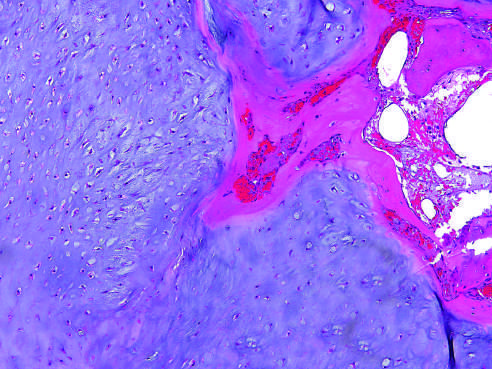s enchondroma composed of a nodule of hyaline cartilage encased by a thin layer of reactive bone?
Answer the question using a single word or phrase. Yes 